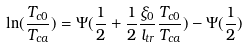<formula> <loc_0><loc_0><loc_500><loc_500>\ln ( \frac { T _ { c 0 } } { T _ { c a } } ) = \Psi ( \frac { 1 } { 2 } + \frac { 1 } { 2 } \frac { \xi _ { 0 } } { l _ { t r } } \frac { T _ { c 0 } } { T _ { c a } } ) - \Psi ( \frac { 1 } { 2 } )</formula> 